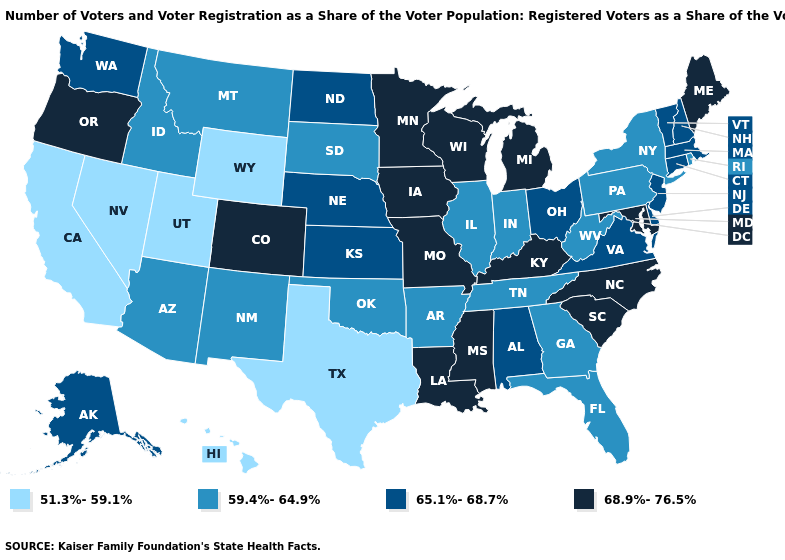Which states have the lowest value in the South?
Give a very brief answer. Texas. What is the value of Kansas?
Give a very brief answer. 65.1%-68.7%. Does the first symbol in the legend represent the smallest category?
Concise answer only. Yes. What is the value of Montana?
Write a very short answer. 59.4%-64.9%. What is the lowest value in the USA?
Short answer required. 51.3%-59.1%. Does California have the lowest value in the West?
Be succinct. Yes. Which states have the highest value in the USA?
Be succinct. Colorado, Iowa, Kentucky, Louisiana, Maine, Maryland, Michigan, Minnesota, Mississippi, Missouri, North Carolina, Oregon, South Carolina, Wisconsin. How many symbols are there in the legend?
Be succinct. 4. What is the value of Alaska?
Write a very short answer. 65.1%-68.7%. What is the highest value in the West ?
Keep it brief. 68.9%-76.5%. Does Minnesota have the same value as Maryland?
Quick response, please. Yes. Name the states that have a value in the range 59.4%-64.9%?
Write a very short answer. Arizona, Arkansas, Florida, Georgia, Idaho, Illinois, Indiana, Montana, New Mexico, New York, Oklahoma, Pennsylvania, Rhode Island, South Dakota, Tennessee, West Virginia. Among the states that border South Dakota , does Wyoming have the lowest value?
Answer briefly. Yes. Name the states that have a value in the range 59.4%-64.9%?
Write a very short answer. Arizona, Arkansas, Florida, Georgia, Idaho, Illinois, Indiana, Montana, New Mexico, New York, Oklahoma, Pennsylvania, Rhode Island, South Dakota, Tennessee, West Virginia. Does Rhode Island have a lower value than Arizona?
Answer briefly. No. 